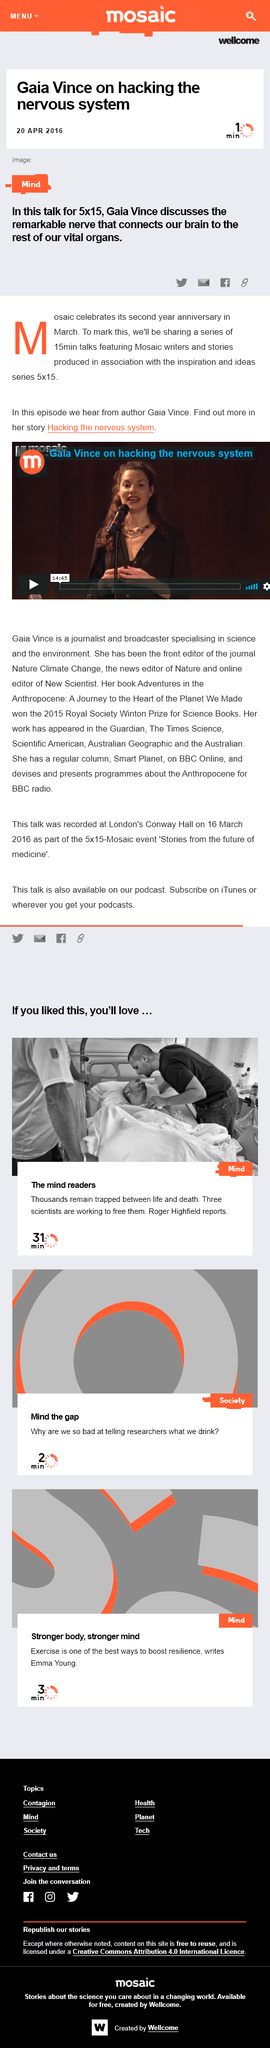List a handful of essential elements in this visual. It is recommended that one should take approximately one minute to read the article. The article was published on 20 April 2016. One can share articles on various platforms such as Twitter, email, Facebook, and by providing a link. 